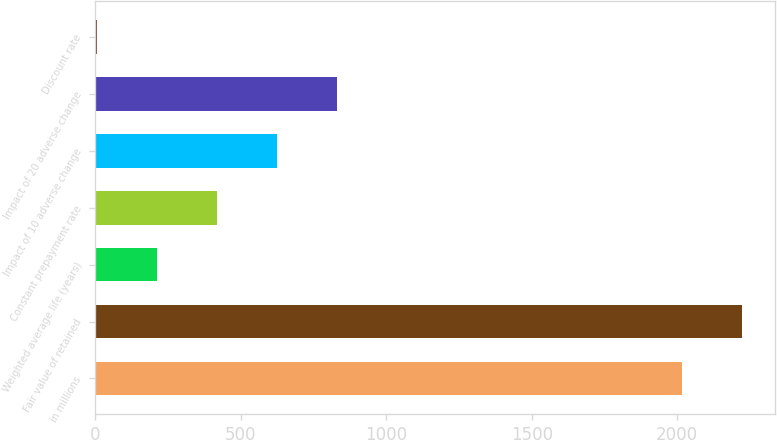<chart> <loc_0><loc_0><loc_500><loc_500><bar_chart><fcel>in millions<fcel>Fair value of retained<fcel>Weighted average life (years)<fcel>Constant prepayment rate<fcel>Impact of 10 adverse change<fcel>Impact of 20 adverse change<fcel>Discount rate<nl><fcel>2017<fcel>2223.68<fcel>210.88<fcel>417.56<fcel>624.24<fcel>830.92<fcel>4.2<nl></chart> 